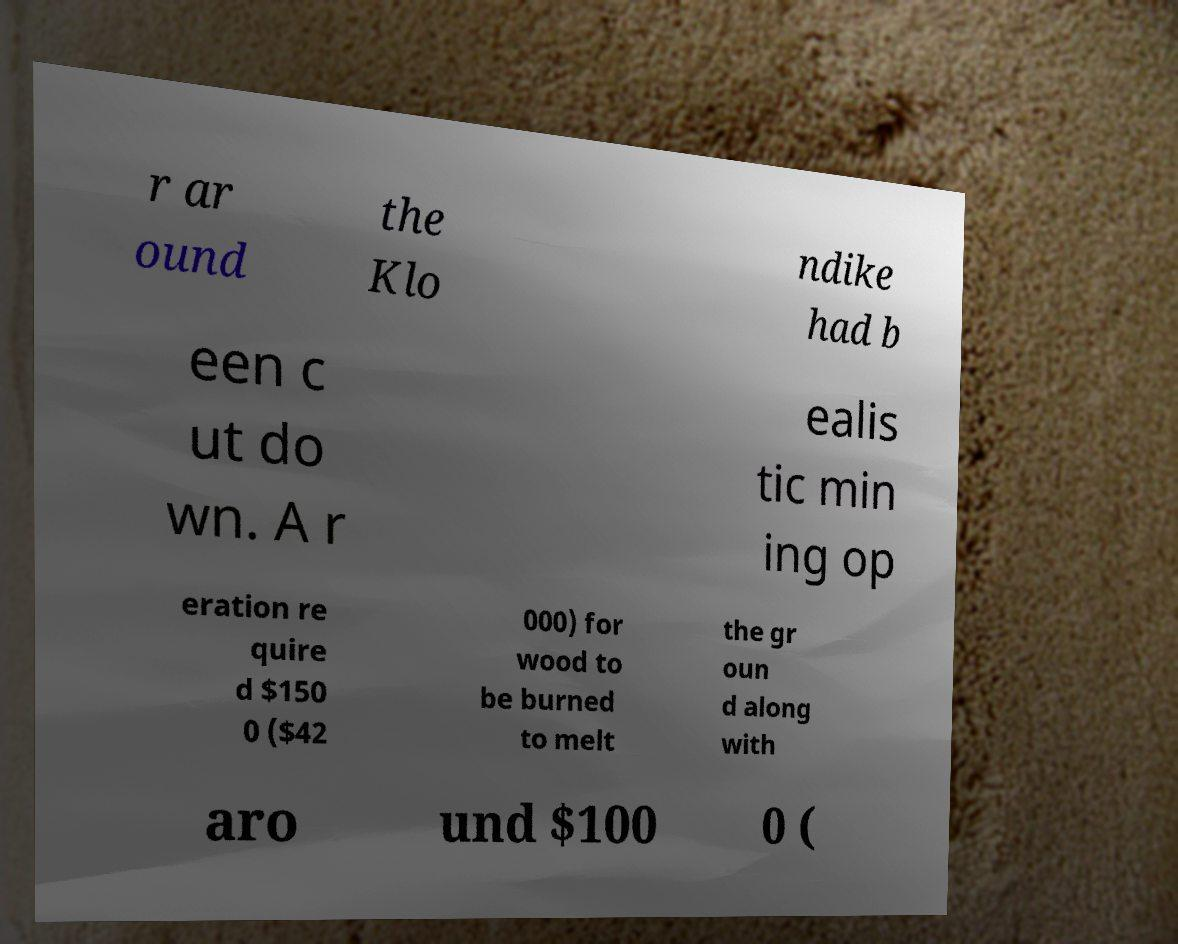Please read and relay the text visible in this image. What does it say? r ar ound the Klo ndike had b een c ut do wn. A r ealis tic min ing op eration re quire d $150 0 ($42 000) for wood to be burned to melt the gr oun d along with aro und $100 0 ( 